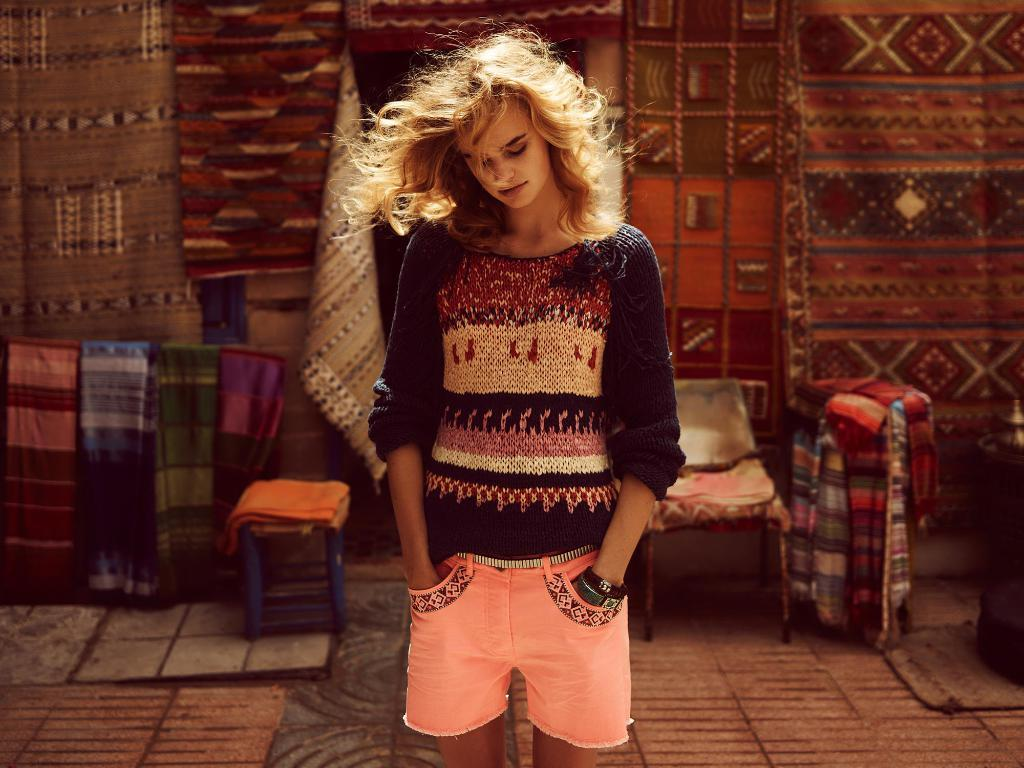Who is the main subject in the image? There is a woman in the image. What is the woman doing with her hands? The woman has her hands in the pockets of her shorts. What is the woman wearing? The woman is wearing a black dress. What can be seen in the background of the image? There are clothes and chairs in the background of the image. What type of knife is the woman using to cut the band in the image? There is no knife or band present in the image. 